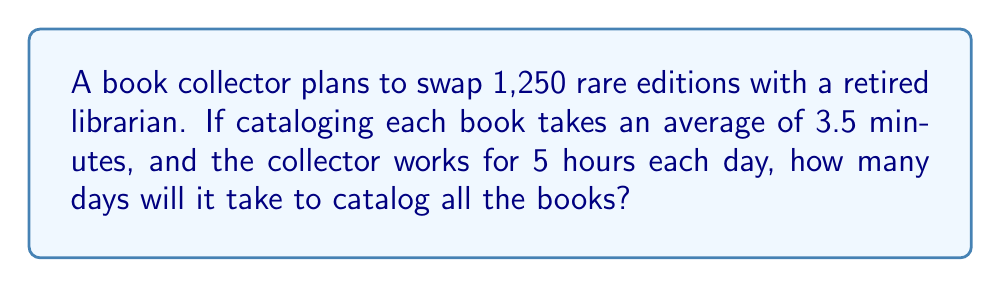Show me your answer to this math problem. To solve this problem, let's follow these steps:

1. Calculate the total time required to catalog all books:
   $$\text{Total time} = 1,250 \text{ books} \times 3.5 \text{ minutes/book} = 4,375 \text{ minutes}$$

2. Convert the total time from minutes to hours:
   $$4,375 \text{ minutes} \div 60 \text{ minutes/hour} = 72.92 \text{ hours}$$

3. Calculate the number of days needed:
   $$\text{Number of days} = \frac{\text{Total hours required}}{\text{Hours worked per day}}$$
   $$\text{Number of days} = \frac{72.92 \text{ hours}}{5 \text{ hours/day}} = 14.58 \text{ days}$$

4. Since we can't work for a partial day, we need to round up to the nearest whole day:
   $$\text{Final answer} = \lceil 14.58 \rceil = 15 \text{ days}$$
Answer: 15 days 